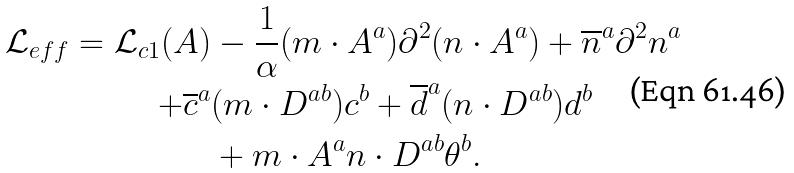<formula> <loc_0><loc_0><loc_500><loc_500>\mathcal { L } _ { e f f } = \mathcal { L } _ { c 1 } ( A ) & - \frac { 1 } { \alpha } ( m \cdot A ^ { a } ) \partial ^ { 2 } ( n \cdot A ^ { a } ) + \overline { n } ^ { a } \partial ^ { 2 } n ^ { a } \\ + \overline { c } ^ { a } & ( m \cdot D ^ { a b } ) c ^ { b } + \overline { d } ^ { a } ( n \cdot D ^ { a b } ) d ^ { b } \\ & + m \cdot A ^ { a } n \cdot D ^ { a b } \theta ^ { b } .</formula> 